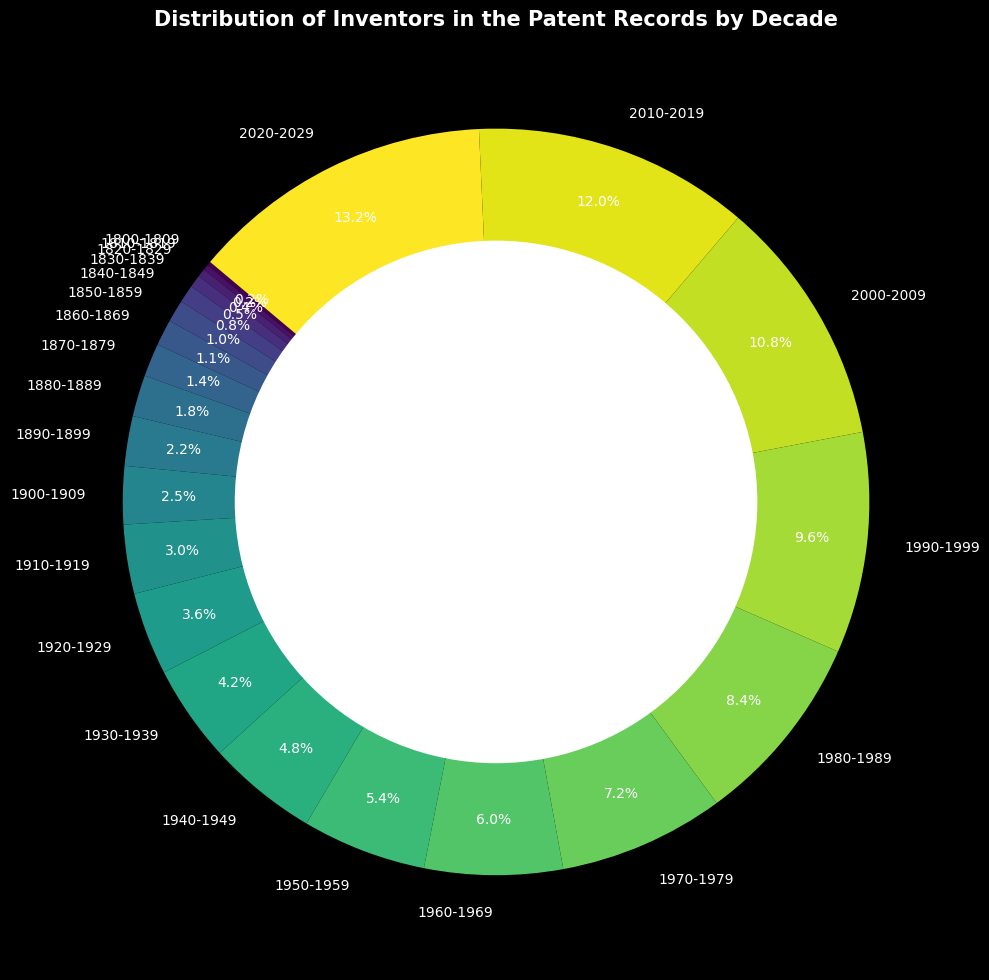Which decade had the highest number of inventors? Look at the section of the ring chart that represents the largest percentage. This section corresponds to the decade 2020-2029.
Answer: 2020-2029 How many inventors were there in the 19th century (1800s)? Add the number of inventors from each decade in the 19th century (1800-1899). 150 (1800s) + 200 (1810s) + 300 (1820s) + 450 (1830s) + 650 (1840s) + 800 (1850s) + 950 (1860s) + 1200 (1870s) + 1500 (1880s) + 1800 (1890s) = 8000
Answer: 8000 What percentage of inventors were recorded in the decades from 2000-2029? Add the percentages for 2000-2009, 2010-2019, and 2020-2029 shown on the chart: 8.2% + 9.1% + 10.0% = 27.3%.
Answer: 27.3% Which two consecutive decades show the highest increase in the number of inventors? Calculate the difference in the number of inventors for each consecutive decade. The largest difference is between 1950-1959 (4500) and 1960-1969 (5000): 5000 - 4500 = 500.
Answer: 1950-1959 and 1960-1969 Compare the number of inventors in the decades 1960-1969 and 1990-1999. Which had more inventors and by how much? Compare the numbers: 1990-1999 (8000) - 1960-1969 (5000) = 3000. The 1990-1999 decade had 3000 more inventors.
Answer: 1990-1999 by 3000 What is the average number of inventors per decade from 1900 to 2000? Sum the inventors from 1900-1909, 1910-1919, ..., 1990-1999 and divide by the number of decades. (2100 + 2500 + 3000 + 3500 + 4000 + 4500 + 5000 + 6000 + 7000 + 8000) / 10 = 4560
Answer: 4560 Between which two decades did the number of inventors first exceed 1000? Look at the number of inventors for each decade and find where it first exceeds 1000. It happens between 1860-1869 (950) and 1870-1879 (1200).
Answer: 1860-1869 and 1870-1879 What is the difference in the number of inventors between the decade with the smallest and largest values? Subtract the smallest value (1800-1809 with 150) from the largest value (2020-2029 with 11000): 11000 - 150 = 10850.
Answer: 10850 Which decade in the 20th century (1900s) had the greatest increase in the number of inventors compared to the previous decade? Compare the increase for each decade. The greatest increase is between 1900-1909 (2100) and 1910-1919 (2500), with an increase of 2500 - 2100 = 400 inventors.
Answer: 1910-1919 How many more inventors were there from 1980-1989 compared to 1970-1979? Subtract the number of inventors in the 1970s from the number in the 1980s: 7000 - 6000 = 1000.
Answer: 1000 